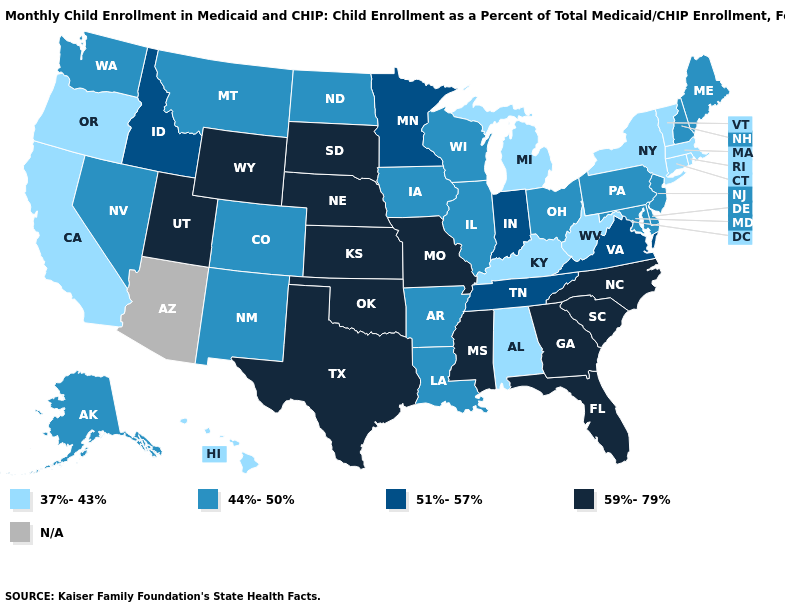What is the value of New Mexico?
Short answer required. 44%-50%. What is the value of Vermont?
Concise answer only. 37%-43%. Does Texas have the highest value in the USA?
Keep it brief. Yes. Name the states that have a value in the range 59%-79%?
Answer briefly. Florida, Georgia, Kansas, Mississippi, Missouri, Nebraska, North Carolina, Oklahoma, South Carolina, South Dakota, Texas, Utah, Wyoming. What is the value of New Hampshire?
Write a very short answer. 44%-50%. What is the value of Ohio?
Short answer required. 44%-50%. Among the states that border Iowa , which have the highest value?
Write a very short answer. Missouri, Nebraska, South Dakota. What is the value of Wyoming?
Be succinct. 59%-79%. Name the states that have a value in the range N/A?
Keep it brief. Arizona. What is the value of North Dakota?
Short answer required. 44%-50%. Name the states that have a value in the range 44%-50%?
Concise answer only. Alaska, Arkansas, Colorado, Delaware, Illinois, Iowa, Louisiana, Maine, Maryland, Montana, Nevada, New Hampshire, New Jersey, New Mexico, North Dakota, Ohio, Pennsylvania, Washington, Wisconsin. Name the states that have a value in the range 44%-50%?
Be succinct. Alaska, Arkansas, Colorado, Delaware, Illinois, Iowa, Louisiana, Maine, Maryland, Montana, Nevada, New Hampshire, New Jersey, New Mexico, North Dakota, Ohio, Pennsylvania, Washington, Wisconsin. What is the highest value in states that border Rhode Island?
Give a very brief answer. 37%-43%. What is the value of Colorado?
Quick response, please. 44%-50%. Name the states that have a value in the range 37%-43%?
Keep it brief. Alabama, California, Connecticut, Hawaii, Kentucky, Massachusetts, Michigan, New York, Oregon, Rhode Island, Vermont, West Virginia. 